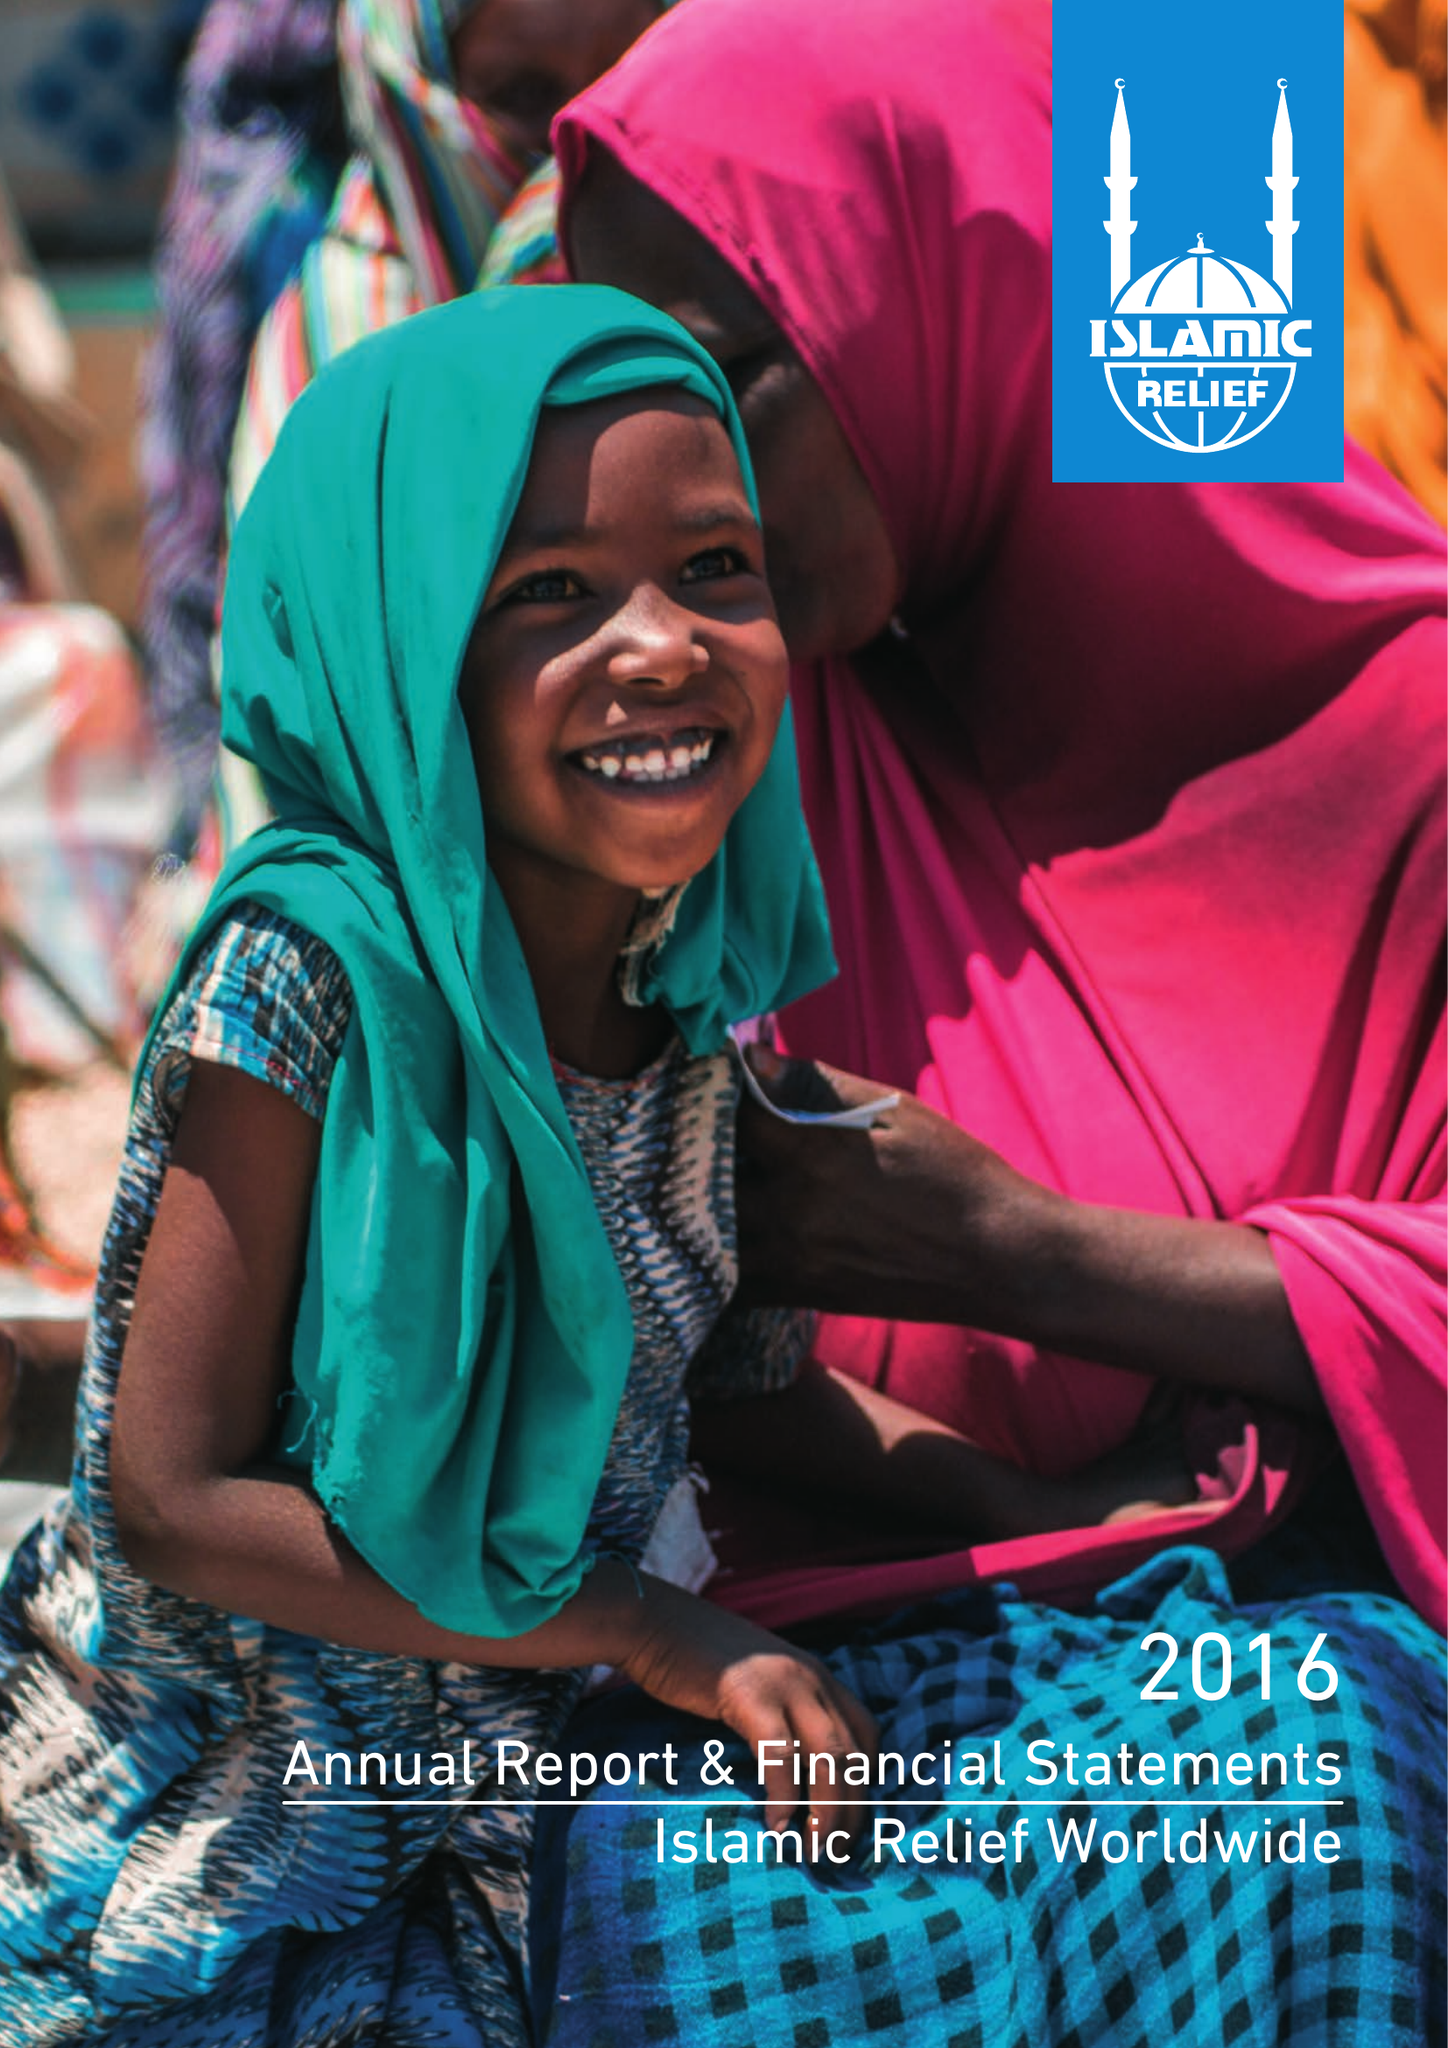What is the value for the income_annually_in_british_pounds?
Answer the question using a single word or phrase. 110395914.00 